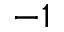<formula> <loc_0><loc_0><loc_500><loc_500>^ { - 1 }</formula> 